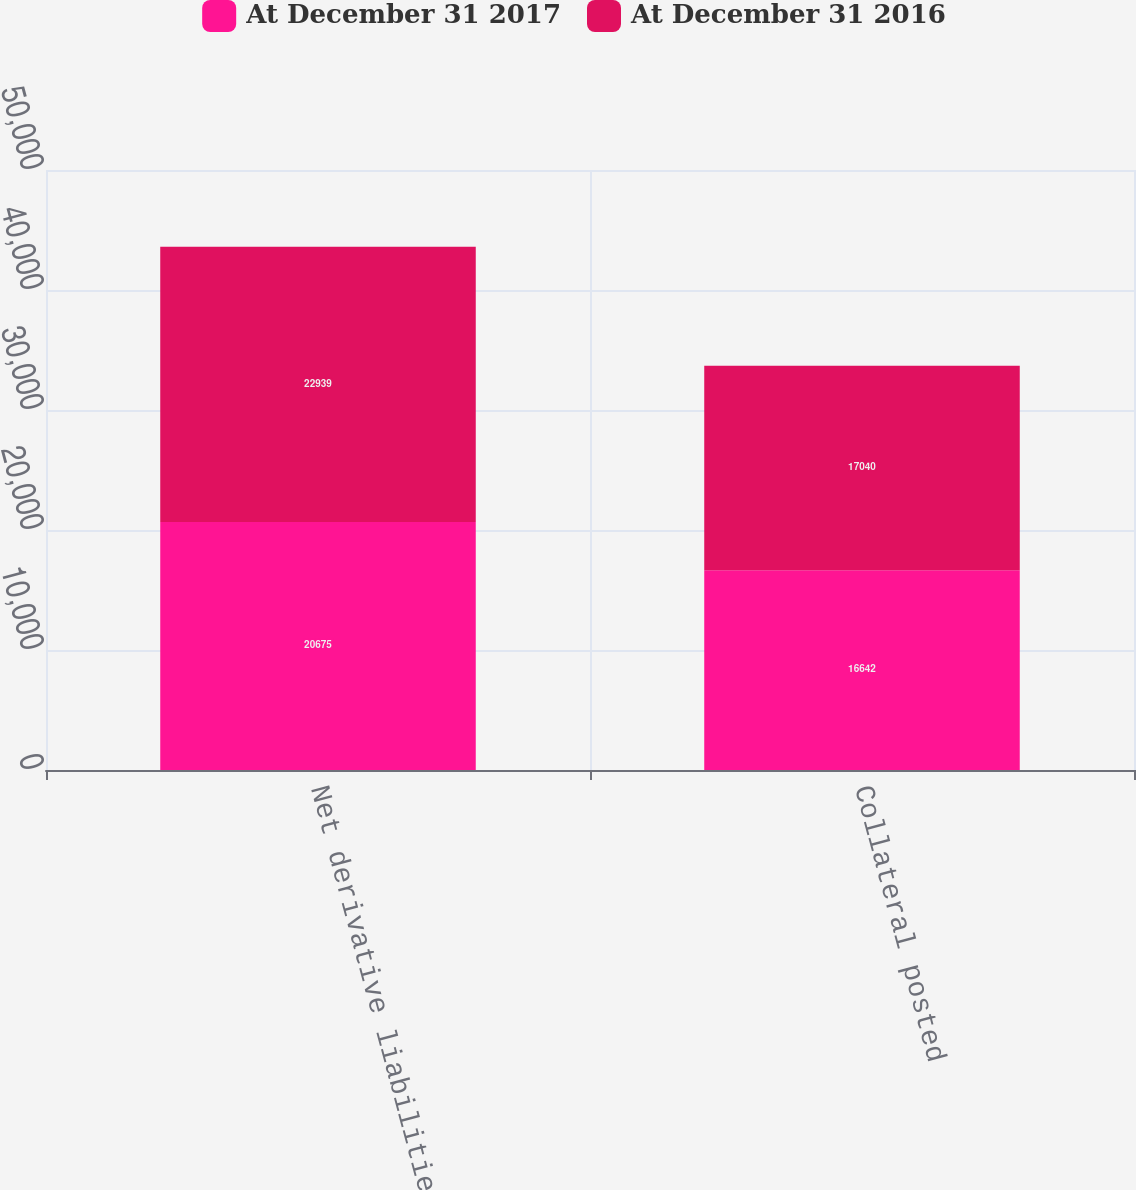Convert chart to OTSL. <chart><loc_0><loc_0><loc_500><loc_500><stacked_bar_chart><ecel><fcel>Net derivative liabilities<fcel>Collateral posted<nl><fcel>At December 31 2017<fcel>20675<fcel>16642<nl><fcel>At December 31 2016<fcel>22939<fcel>17040<nl></chart> 